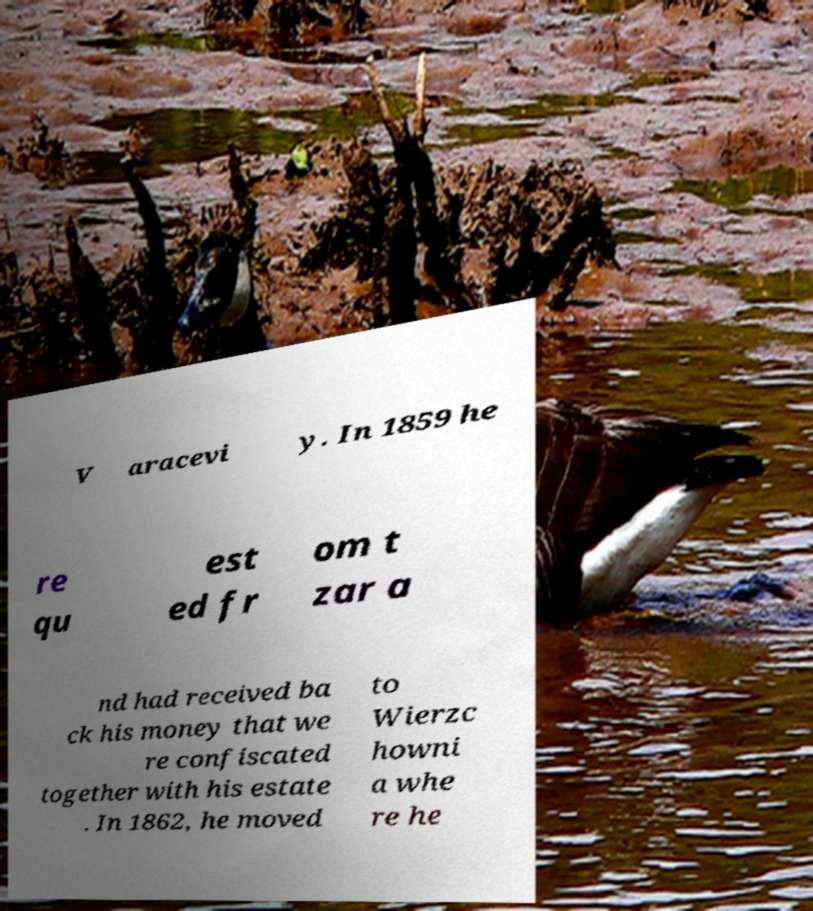Could you assist in decoding the text presented in this image and type it out clearly? V aracevi y. In 1859 he re qu est ed fr om t zar a nd had received ba ck his money that we re confiscated together with his estate . In 1862, he moved to Wierzc howni a whe re he 